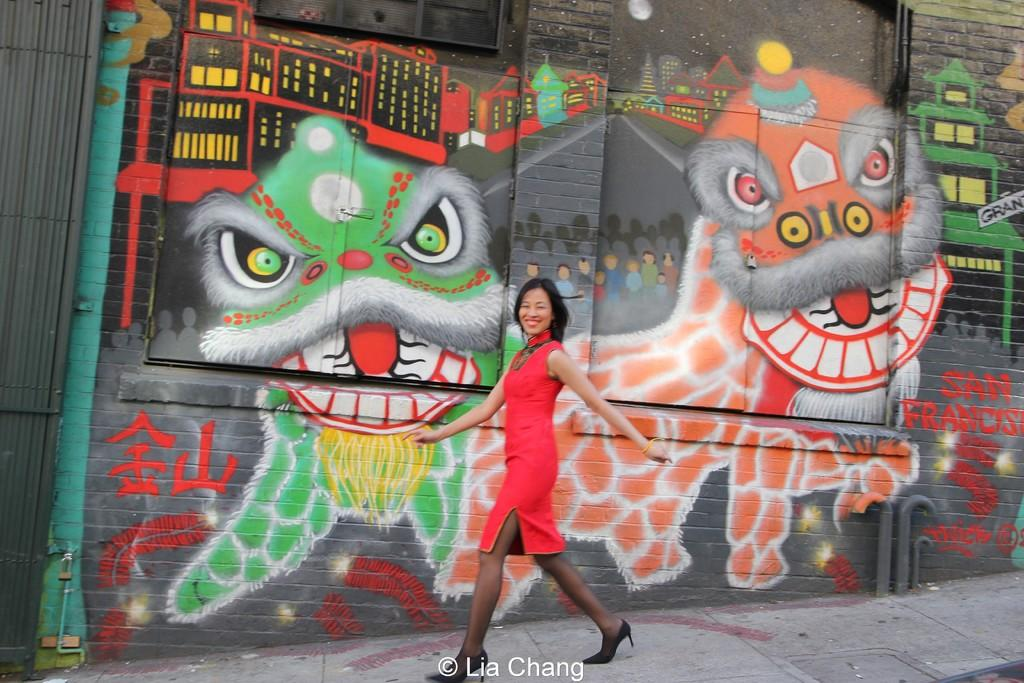Who is present in the image? There is a person in the image. What is the person doing in the image? The person is walking and smiling. What can be seen in the background of the image? There is a wall in the background of the image. What is on the wall in the image? The wall has images painted on it. What type of pickle is the person holding in the image? There is no pickle present in the image; the person is walking and smiling. What advice does the person's mom give them in the image? There is no reference to the person's mom or any advice in the image. 